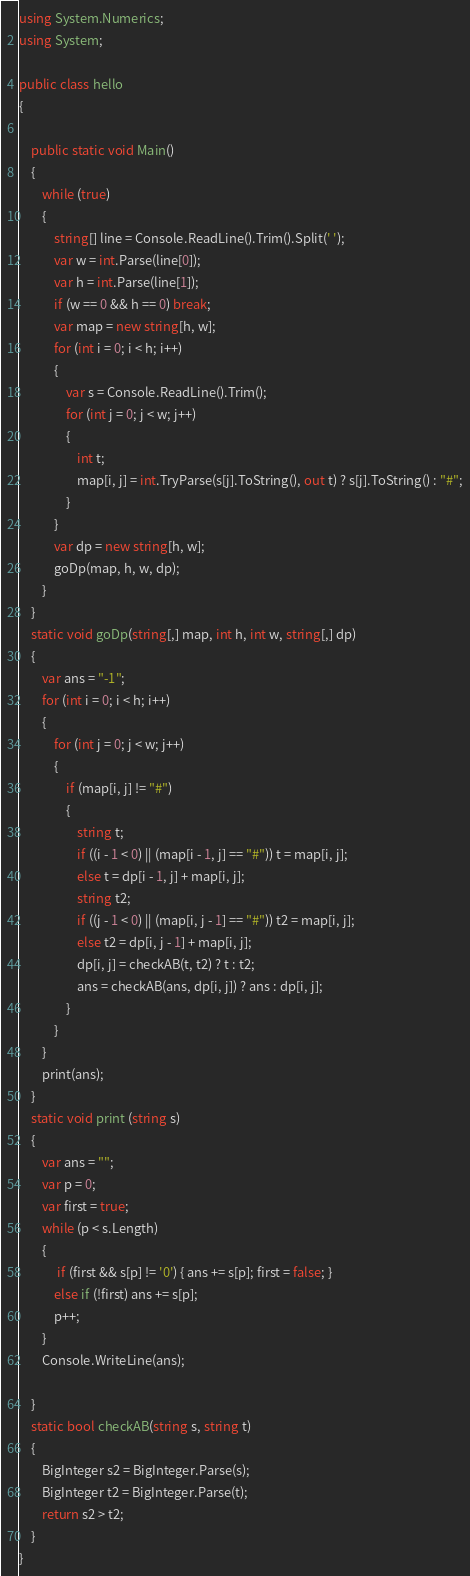Convert code to text. <code><loc_0><loc_0><loc_500><loc_500><_C#_>using System.Numerics;
using System;

public class hello
{

    public static void Main()
    {
        while (true)
        {
            string[] line = Console.ReadLine().Trim().Split(' ');
            var w = int.Parse(line[0]);
            var h = int.Parse(line[1]);
            if (w == 0 && h == 0) break;
            var map = new string[h, w];
            for (int i = 0; i < h; i++)
            {
                var s = Console.ReadLine().Trim();
                for (int j = 0; j < w; j++)
                {
                    int t;
                    map[i, j] = int.TryParse(s[j].ToString(), out t) ? s[j].ToString() : "#";
                }
            }
            var dp = new string[h, w];
            goDp(map, h, w, dp);
        }
    }
    static void goDp(string[,] map, int h, int w, string[,] dp)
    {
        var ans = "-1";
        for (int i = 0; i < h; i++)
        {
            for (int j = 0; j < w; j++)
            {
                if (map[i, j] != "#")
                {
                    string t;
                    if ((i - 1 < 0) || (map[i - 1, j] == "#")) t = map[i, j];
                    else t = dp[i - 1, j] + map[i, j];
                    string t2;
                    if ((j - 1 < 0) || (map[i, j - 1] == "#")) t2 = map[i, j];
                    else t2 = dp[i, j - 1] + map[i, j];
                    dp[i, j] = checkAB(t, t2) ? t : t2;
                    ans = checkAB(ans, dp[i, j]) ? ans : dp[i, j];
                }
            }
        }
        print(ans);
    }
    static void print (string s)
    {
        var ans = "";
        var p = 0;
        var first = true;
        while (p < s.Length)
        {
             if (first && s[p] != '0') { ans += s[p]; first = false; }
            else if (!first) ans += s[p];
            p++;
        }
        Console.WriteLine(ans);

    }
    static bool checkAB(string s, string t)
    {
        BigInteger s2 = BigInteger.Parse(s);
        BigInteger t2 = BigInteger.Parse(t);
        return s2 > t2;
    }
}

</code> 